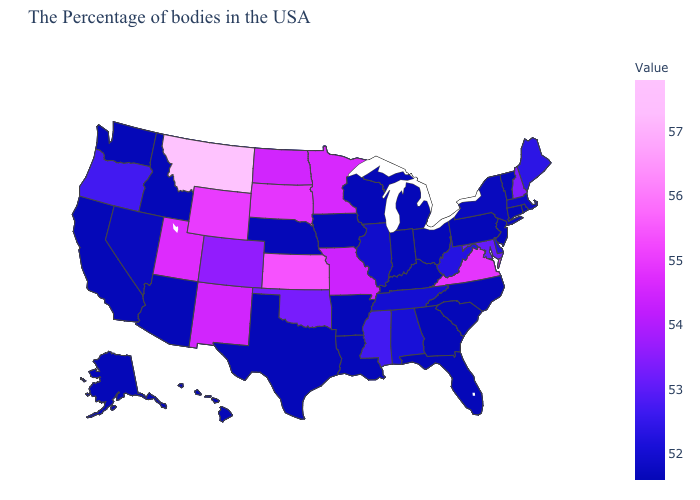Which states hav the highest value in the Northeast?
Write a very short answer. New Hampshire. Which states hav the highest value in the Northeast?
Write a very short answer. New Hampshire. Which states have the lowest value in the USA?
Concise answer only. Rhode Island, Vermont, Connecticut, New Jersey, Pennsylvania, North Carolina, South Carolina, Ohio, Florida, Georgia, Michigan, Kentucky, Indiana, Wisconsin, Louisiana, Arkansas, Iowa, Nebraska, Texas, Arizona, Idaho, California, Washington, Alaska, Hawaii. 